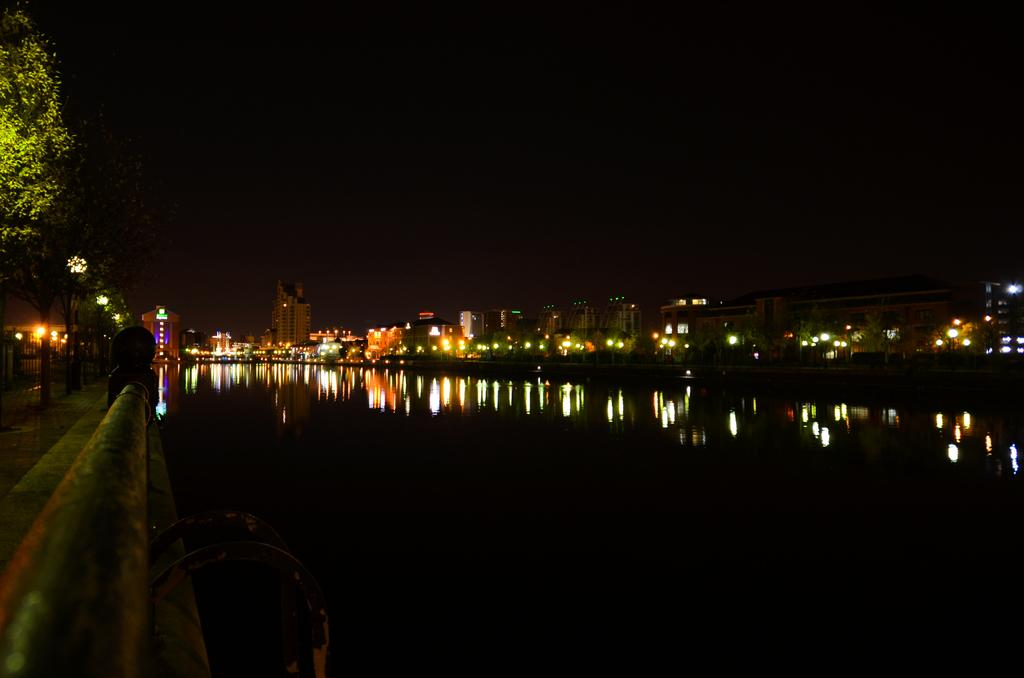What type of barrier can be seen in the image? There is a fence in the image. What type of vegetation is present in the image? There are trees in the left corner of the image. What is located beside the fence? There is water beside the fence. What can be seen in the distance in the image? There are buildings and lights in the background of the image. How does the society of the image begin to change in the presence of a bit? There is no mention of society, change, or a bit in the image, so this question cannot be answered. 